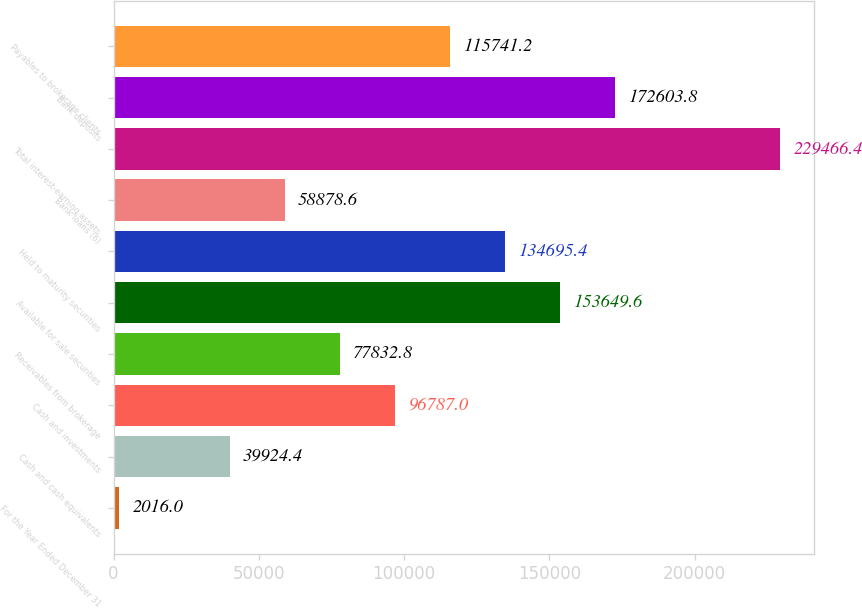Convert chart to OTSL. <chart><loc_0><loc_0><loc_500><loc_500><bar_chart><fcel>For the Year Ended December 31<fcel>Cash and cash equivalents<fcel>Cash and investments<fcel>Receivables from brokerage<fcel>Available for sale securities<fcel>Held to maturity securities<fcel>Bank loans (6)<fcel>Total interest-earning assets<fcel>Bank deposits<fcel>Payables to brokerage clients<nl><fcel>2016<fcel>39924.4<fcel>96787<fcel>77832.8<fcel>153650<fcel>134695<fcel>58878.6<fcel>229466<fcel>172604<fcel>115741<nl></chart> 